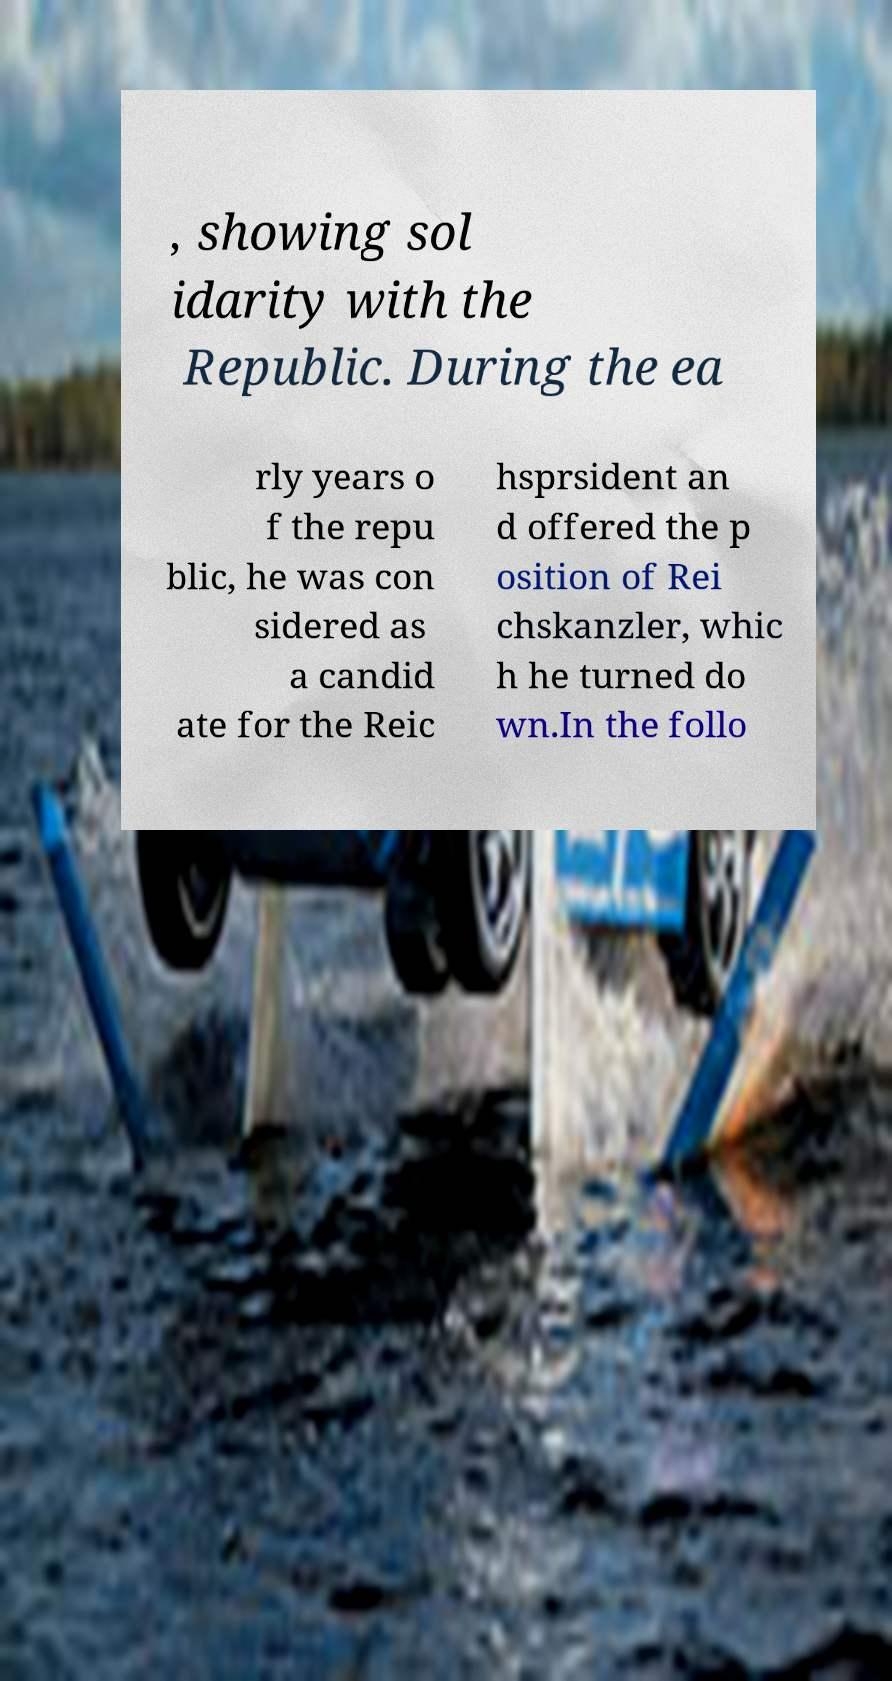Please read and relay the text visible in this image. What does it say? , showing sol idarity with the Republic. During the ea rly years o f the repu blic, he was con sidered as a candid ate for the Reic hsprsident an d offered the p osition of Rei chskanzler, whic h he turned do wn.In the follo 